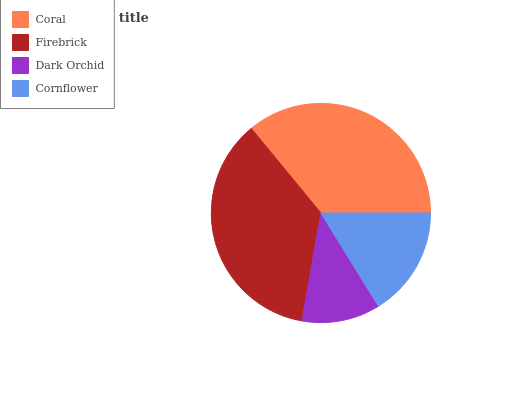Is Dark Orchid the minimum?
Answer yes or no. Yes. Is Firebrick the maximum?
Answer yes or no. Yes. Is Firebrick the minimum?
Answer yes or no. No. Is Dark Orchid the maximum?
Answer yes or no. No. Is Firebrick greater than Dark Orchid?
Answer yes or no. Yes. Is Dark Orchid less than Firebrick?
Answer yes or no. Yes. Is Dark Orchid greater than Firebrick?
Answer yes or no. No. Is Firebrick less than Dark Orchid?
Answer yes or no. No. Is Coral the high median?
Answer yes or no. Yes. Is Cornflower the low median?
Answer yes or no. Yes. Is Firebrick the high median?
Answer yes or no. No. Is Firebrick the low median?
Answer yes or no. No. 